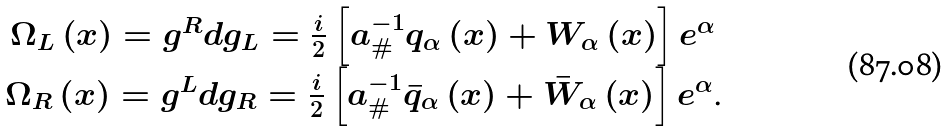Convert formula to latex. <formula><loc_0><loc_0><loc_500><loc_500>\begin{array} { c } \Omega _ { L } \left ( x \right ) = g ^ { R } d g _ { L } = \frac { i } { 2 } \left [ a _ { \# } ^ { - 1 } q _ { \alpha } \left ( x \right ) + W _ { \alpha } \left ( x \right ) \right ] e ^ { \alpha } \\ \Omega _ { R } \left ( x \right ) = g ^ { L } d g _ { R } = \frac { i } { 2 } \left [ a _ { \# } ^ { - 1 } \bar { q } _ { \alpha } \left ( x \right ) + \bar { W } _ { \alpha } \left ( x \right ) \right ] e ^ { \alpha } \text {.} \end{array}</formula> 